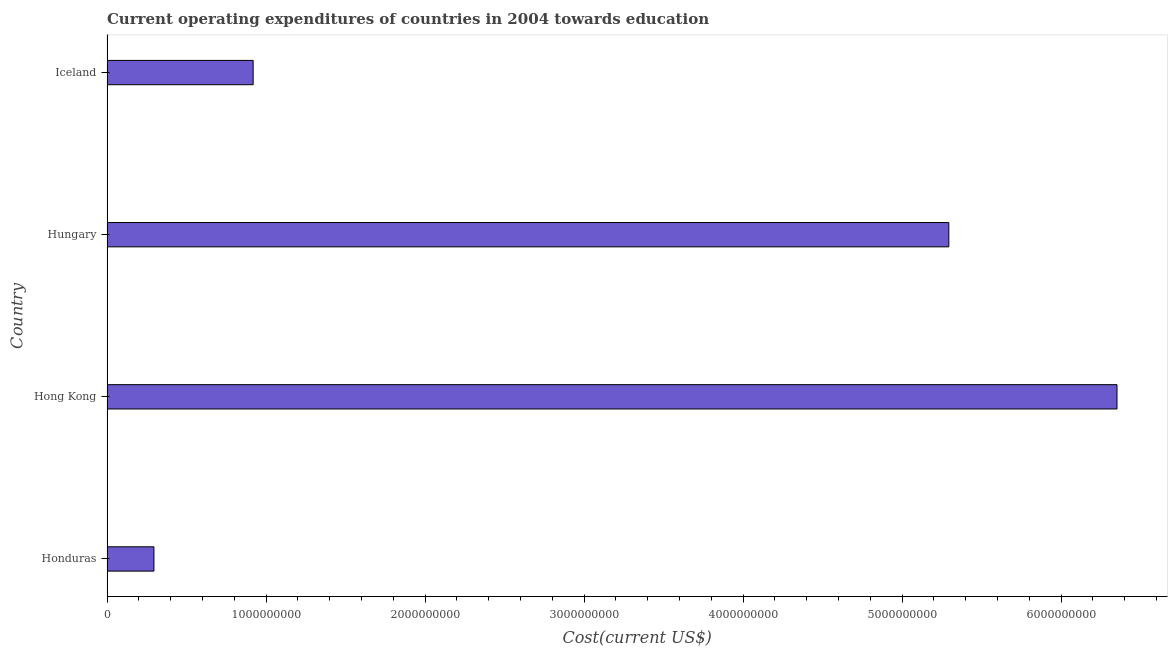Does the graph contain grids?
Your response must be concise. No. What is the title of the graph?
Make the answer very short. Current operating expenditures of countries in 2004 towards education. What is the label or title of the X-axis?
Keep it short and to the point. Cost(current US$). What is the label or title of the Y-axis?
Make the answer very short. Country. What is the education expenditure in Hong Kong?
Your response must be concise. 6.35e+09. Across all countries, what is the maximum education expenditure?
Ensure brevity in your answer.  6.35e+09. Across all countries, what is the minimum education expenditure?
Offer a terse response. 2.95e+08. In which country was the education expenditure maximum?
Your answer should be very brief. Hong Kong. In which country was the education expenditure minimum?
Make the answer very short. Honduras. What is the sum of the education expenditure?
Your response must be concise. 1.29e+1. What is the difference between the education expenditure in Honduras and Hungary?
Offer a terse response. -5.00e+09. What is the average education expenditure per country?
Make the answer very short. 3.22e+09. What is the median education expenditure?
Ensure brevity in your answer.  3.11e+09. What is the ratio of the education expenditure in Honduras to that in Hong Kong?
Your answer should be very brief. 0.05. Is the education expenditure in Honduras less than that in Iceland?
Provide a short and direct response. Yes. What is the difference between the highest and the second highest education expenditure?
Your answer should be very brief. 1.06e+09. What is the difference between the highest and the lowest education expenditure?
Your answer should be compact. 6.06e+09. In how many countries, is the education expenditure greater than the average education expenditure taken over all countries?
Make the answer very short. 2. Are all the bars in the graph horizontal?
Give a very brief answer. Yes. What is the difference between two consecutive major ticks on the X-axis?
Offer a very short reply. 1.00e+09. What is the Cost(current US$) of Honduras?
Give a very brief answer. 2.95e+08. What is the Cost(current US$) in Hong Kong?
Provide a succinct answer. 6.35e+09. What is the Cost(current US$) of Hungary?
Your response must be concise. 5.29e+09. What is the Cost(current US$) of Iceland?
Your response must be concise. 9.19e+08. What is the difference between the Cost(current US$) in Honduras and Hong Kong?
Keep it short and to the point. -6.06e+09. What is the difference between the Cost(current US$) in Honduras and Hungary?
Your answer should be very brief. -5.00e+09. What is the difference between the Cost(current US$) in Honduras and Iceland?
Keep it short and to the point. -6.24e+08. What is the difference between the Cost(current US$) in Hong Kong and Hungary?
Your answer should be very brief. 1.06e+09. What is the difference between the Cost(current US$) in Hong Kong and Iceland?
Offer a terse response. 5.43e+09. What is the difference between the Cost(current US$) in Hungary and Iceland?
Offer a very short reply. 4.38e+09. What is the ratio of the Cost(current US$) in Honduras to that in Hong Kong?
Make the answer very short. 0.05. What is the ratio of the Cost(current US$) in Honduras to that in Hungary?
Provide a short and direct response. 0.06. What is the ratio of the Cost(current US$) in Honduras to that in Iceland?
Your answer should be very brief. 0.32. What is the ratio of the Cost(current US$) in Hong Kong to that in Iceland?
Ensure brevity in your answer.  6.91. What is the ratio of the Cost(current US$) in Hungary to that in Iceland?
Offer a terse response. 5.76. 